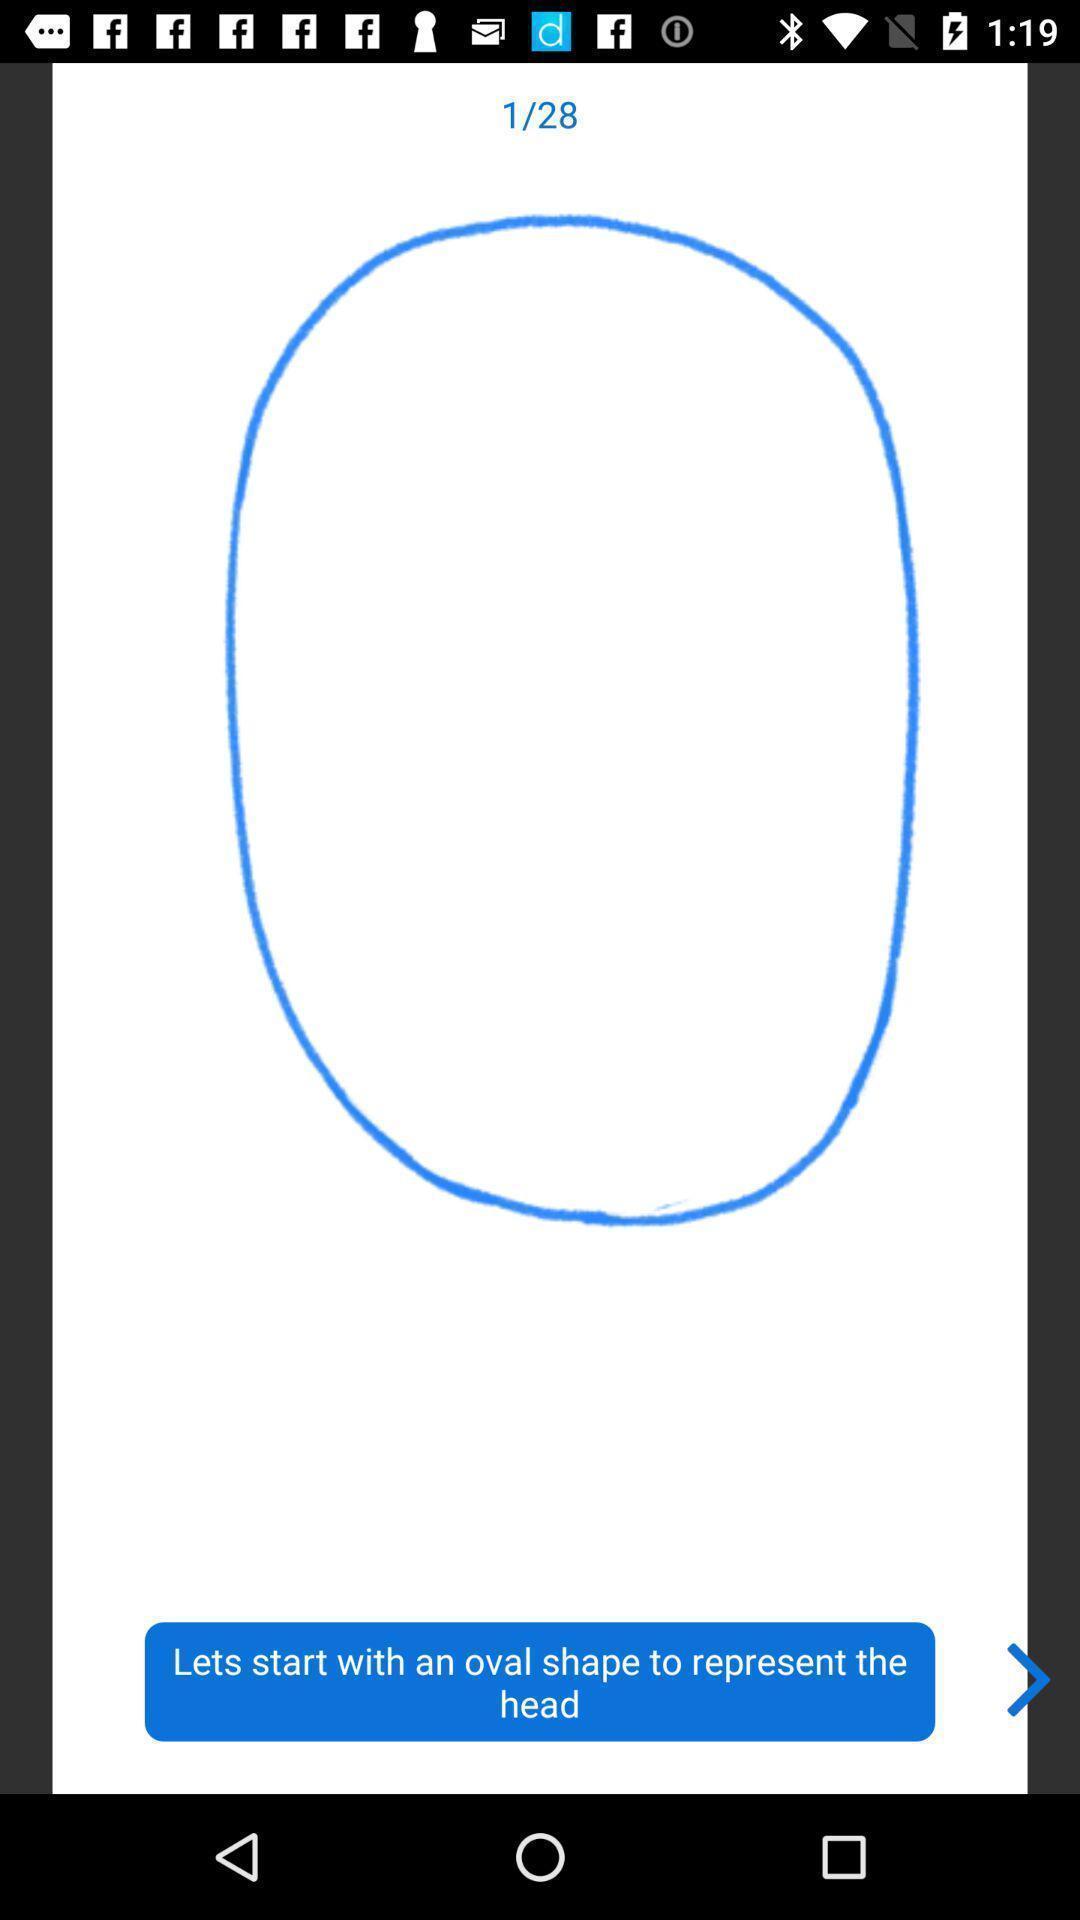Please provide a description for this image. Start page of a painting app. 